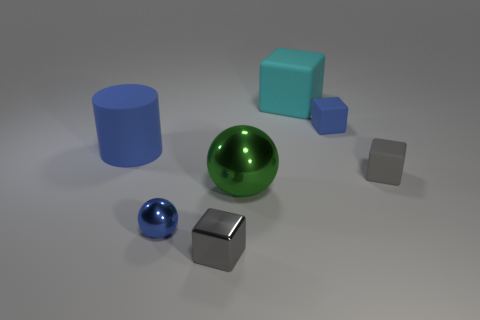Add 1 big green metal things. How many objects exist? 8 Subtract all cylinders. How many objects are left? 6 Add 6 large cyan objects. How many large cyan objects are left? 7 Add 6 gray metallic objects. How many gray metallic objects exist? 7 Subtract 0 yellow balls. How many objects are left? 7 Subtract all small things. Subtract all large matte cubes. How many objects are left? 2 